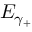<formula> <loc_0><loc_0><loc_500><loc_500>E _ { \gamma _ { + } }</formula> 